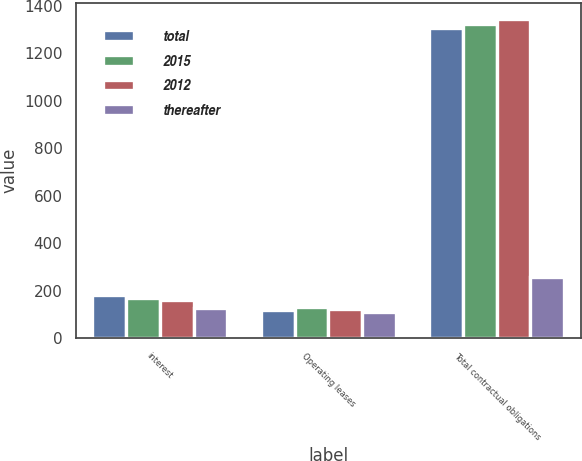<chart> <loc_0><loc_0><loc_500><loc_500><stacked_bar_chart><ecel><fcel>interest<fcel>Operating leases<fcel>Total contractual obligations<nl><fcel>total<fcel>180<fcel>120<fcel>1307<nl><fcel>2015<fcel>169<fcel>131<fcel>1324<nl><fcel>2012<fcel>161<fcel>121<fcel>1347<nl><fcel>thereafter<fcel>126<fcel>110<fcel>258<nl></chart> 